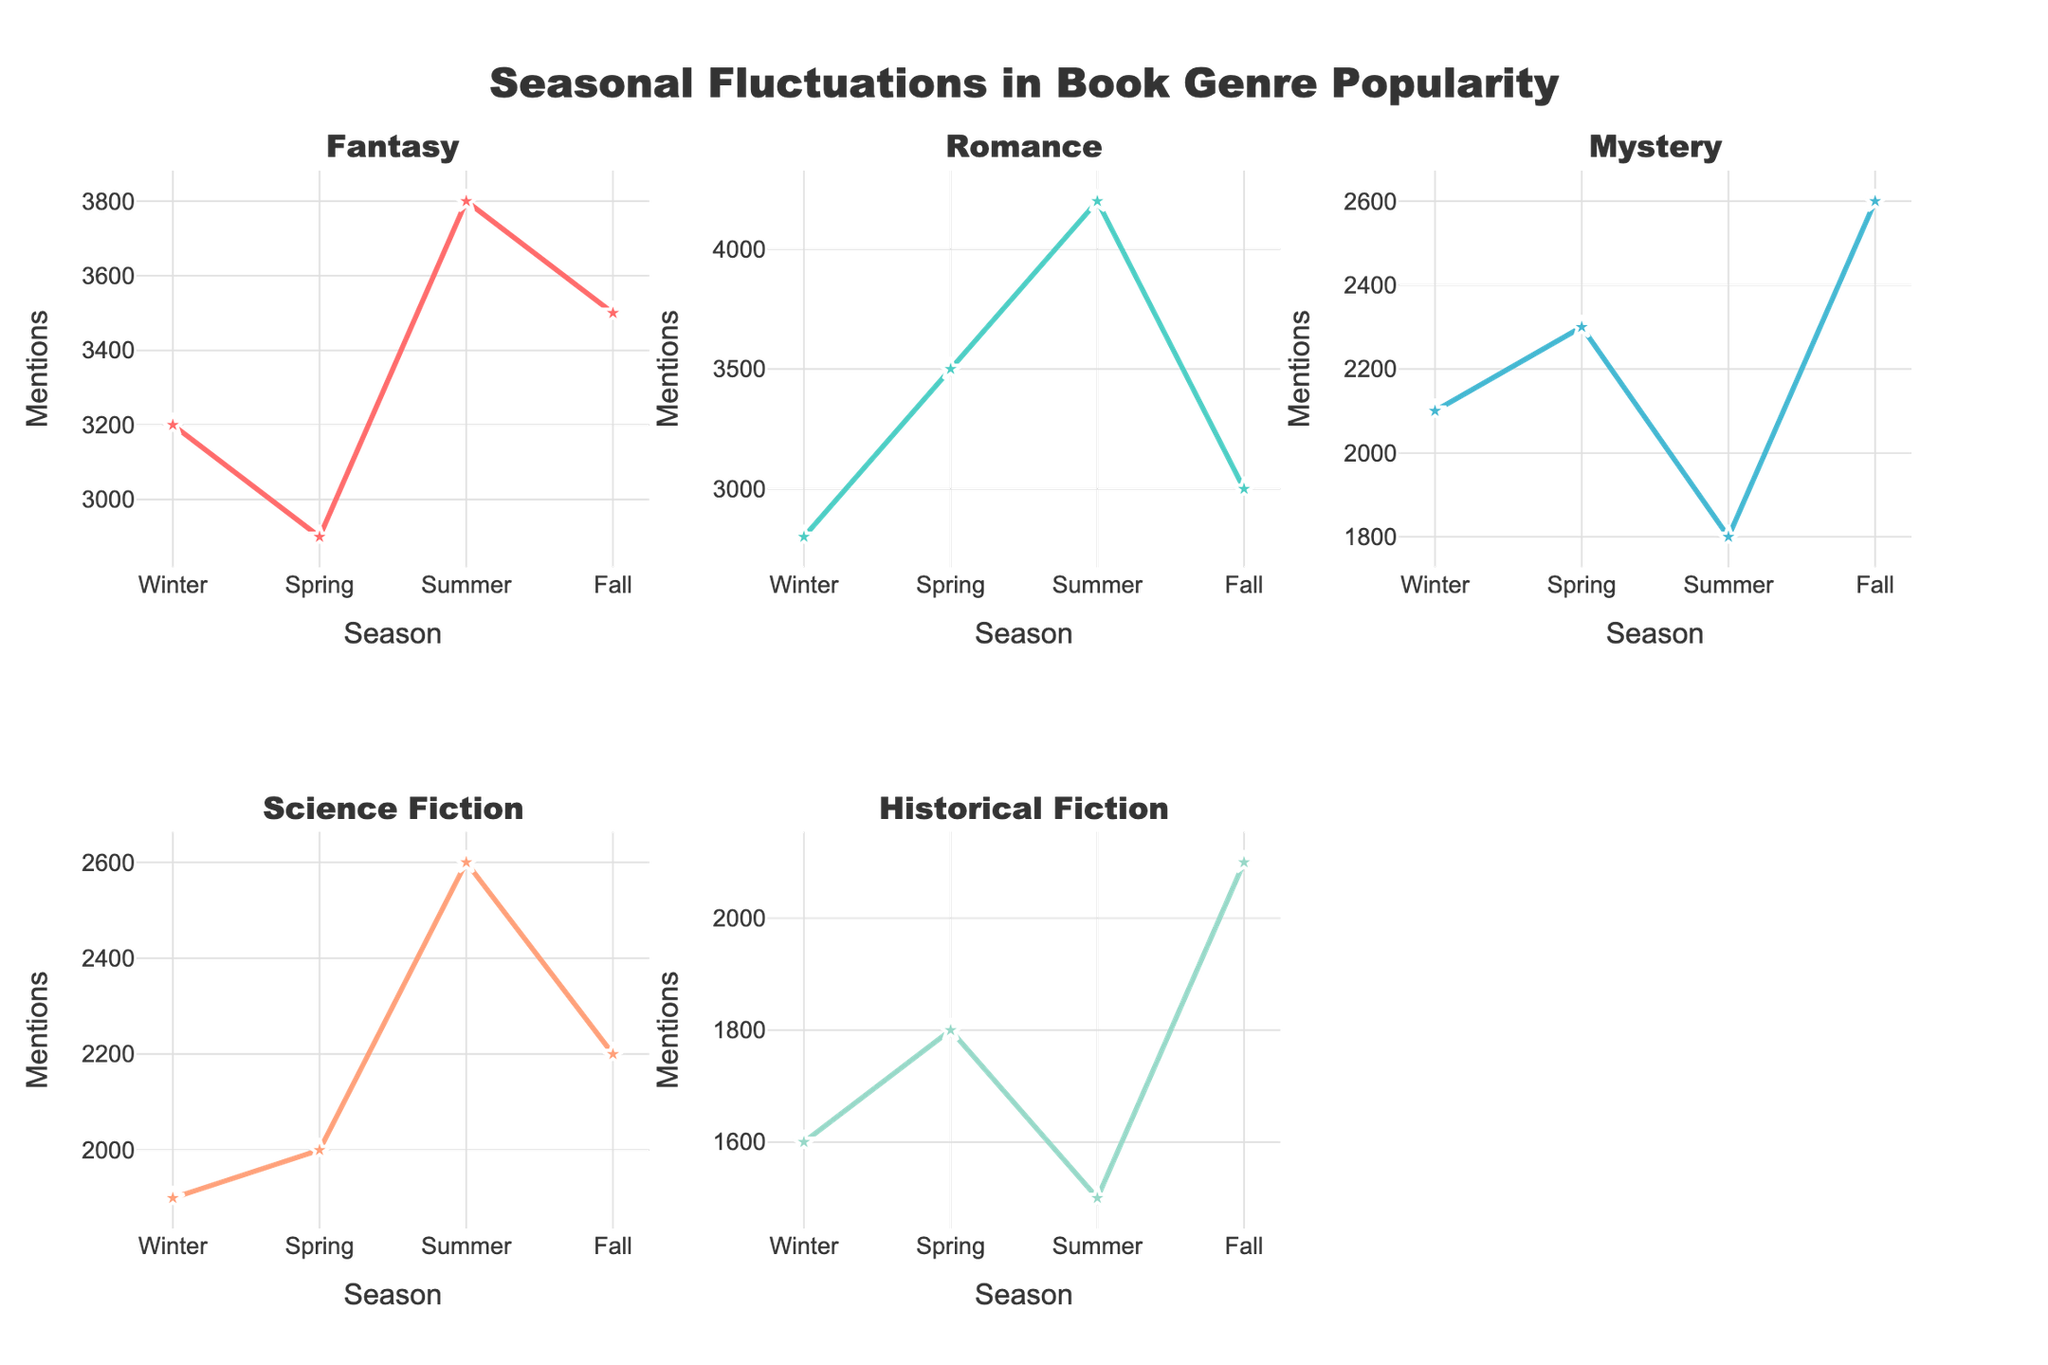Which genre has the highest number of mentions in the summer? From the figure, locate the subplot for each genre, then identify the data point for summer. The genre with the highest point in the summer will be the answer.
Answer: Fantasy Which season has the least mentions for Mystery books? Refer to the subplot for Mystery, and find the lowest point across the seasons. The corresponding season is the answer.
Answer: Summer What is the trend of mentions for Science Fiction books from winter to fall? Observe the subplot for Science Fiction, and track the line connecting the data points from winter to fall. Describe whether it is increasing, decreasing, or fluctuating.
Answer: Fluctuating How much do Romance mentions increase from winter to summer? In the Romance subplot, note the mentions for winter and summer. Subtract winter mentions from summer mentions to get the increase.
Answer: 1400 Compare the number of mentions for Historical Fiction in winter and fall. Which is higher? Check the subplot for Historical Fiction and compare data points for winter and fall. Identify which season has a higher value.
Answer: Fall Which genre shows a dip in mentions during summer? Look through each subplot and observe which genre's line drops in summer, indicating a dip in mentions.
Answer: Mystery What is the average number of mentions for Fantasy books across all seasons? Add up the mentions for Fantasy for all seasons and divide by the number of seasons (4). The sum is (3200+2900+3800+3500) = 13400, so the average is 13400/4.
Answer: 3350 Compare mentions of Romance books in spring and fall. Which season has more mentions, and by how much? Check the Romance subplot and compare the data points for spring and fall. Subtract the fall mentions from spring mentions.
Answer: Spring, 500 more Which single genre has the largest decrease in mentions from one season to the next, and which seasons are involved? Identify the subplot with the steepest drop in line between any two consecutive seasons. Specify the genre and the seasons involved.
Answer: Romance, from summer to fall What is the overall trend for Historical Fiction mentions? Look at the entire subplot for Historical Fiction and describe the general direction of the line from winter to fall.
Answer: Stable with slight fluctuation 